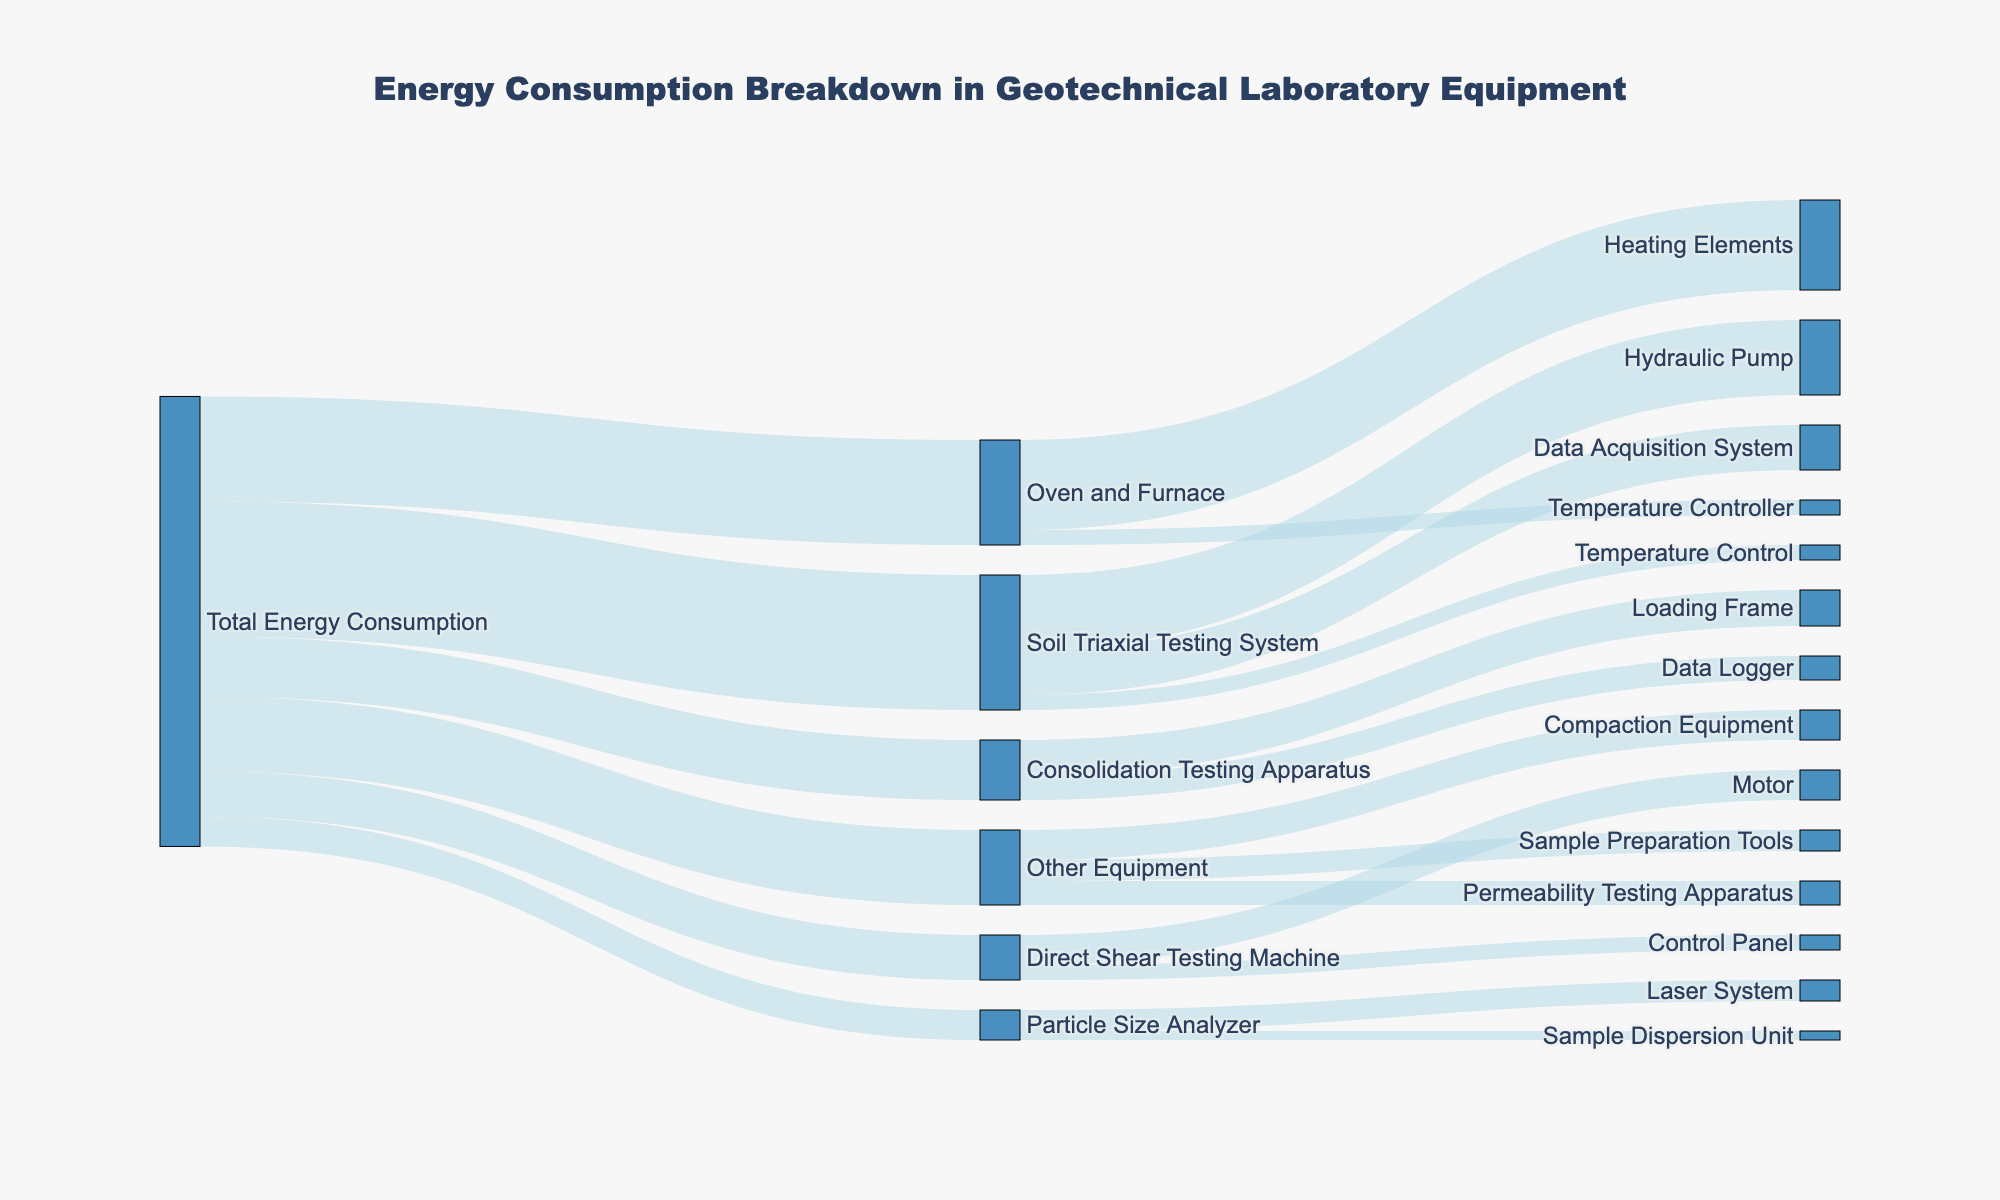What is the title of the Sankey Diagram? The title of the Sankey Diagram is located at the top center of the diagram. It provides an overview of the figure's content.
Answer: Energy Consumption Breakdown in Geotechnical Laboratory Equipment How much energy does the Soil Triaxial Testing System consume? The value connecting the Total Energy Consumption to the Soil Triaxial Testing System indicates the amount of energy consumed.
Answer: 45 Which sub-component of the Soil Triaxial Testing System consumes the most energy? By examining the links from the Soil Triaxial Testing System, we can see which one has the highest value.
Answer: Hydraulic Pump How much energy does the Hydraulic Pump consume compared to the entire Soil Triaxial Testing System? Check the value of energy consumed by the Hydraulic Pump and compare it to the total energy of the Soil Triaxial Testing System. Calculation: 25 compared to 45.
Answer: 25 out of 45 What is the total energy consumption for "Other Equipment"? The value connecting the Total Energy Consumption to Other Equipment indicates the amount of energy consumed.
Answer: 25 Compare the energy consumption of the Oven and Furnace to the Consolidation Testing Apparatus. Compare the values connecting the Total Energy Consumption to both the Oven and Furnace and the Consolidation Testing Apparatus. Calculation: Oven and Furnace (35) vs Consolidation Testing Apparatus (20).
Answer: Oven and Furnace consumes more What sub-component of the Oven and Furnace consumes the least amount of energy? By examining the links from the Oven and Furnace, identify the one with the lowest value.
Answer: Temperature Controller Combine the energy consumption of the Laser System and the Sample Dispersion Unit of the Particle Size Analyzer. Sum the values of the Laser System and the Sample Dispersion Unit. Calculation: 7 + 3.
Answer: 10 What percentage of the Total Energy Consumption is used by the Direct Shear Testing Machine? Find the proportion of energy consumed by the Direct Shear Testing Machine relative to the Total Energy Consumption, then convert it into a percentage. Calculation: (15 / (45 + 20 + 15 + 10 + 35 + 25)) * 100%.
Answer: 10% Which testing system consumes the least energy among the given options? Compare the energy consumption values for each of the testing systems.
Answer: Particle Size Analyzer 